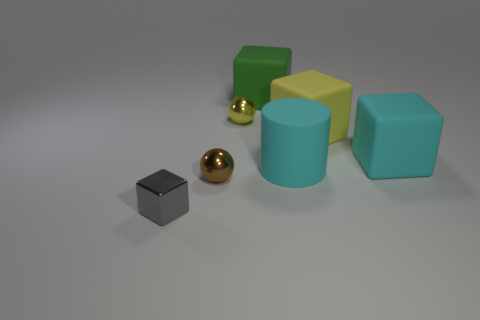Can you describe how the objects might relate to one another based on their spatial arrangement? The spatial arrangement in the image suggests a sense of progression or hierarchy. The smaller metallic sphere could represent a starting point or a core idea, leading up to the larger cyan block, which might metaphorically represent a goal or a major outcome, following the path set by the intermediary blocks. 